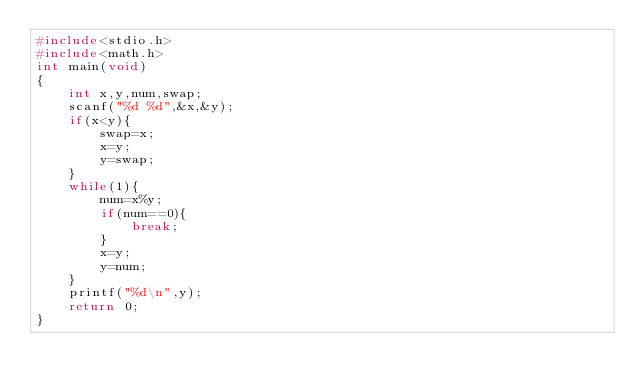Convert code to text. <code><loc_0><loc_0><loc_500><loc_500><_C_>#include<stdio.h>
#include<math.h>
int main(void)
{
    int x,y,num,swap;
    scanf("%d %d",&x,&y);
    if(x<y){
        swap=x;
        x=y;
        y=swap;
    }
    while(1){
        num=x%y;
        if(num==0){
            break;
        }
        x=y;
        y=num;
    }
    printf("%d\n",y);
    return 0;
}
</code> 